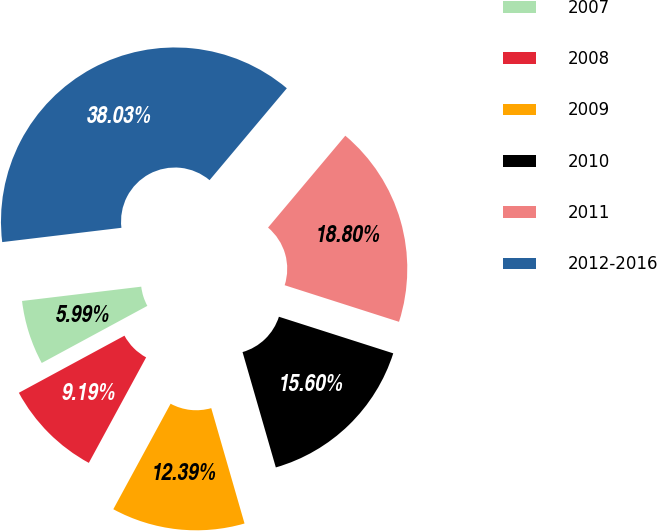Convert chart to OTSL. <chart><loc_0><loc_0><loc_500><loc_500><pie_chart><fcel>2007<fcel>2008<fcel>2009<fcel>2010<fcel>2011<fcel>2012-2016<nl><fcel>5.99%<fcel>9.19%<fcel>12.39%<fcel>15.6%<fcel>18.8%<fcel>38.03%<nl></chart> 